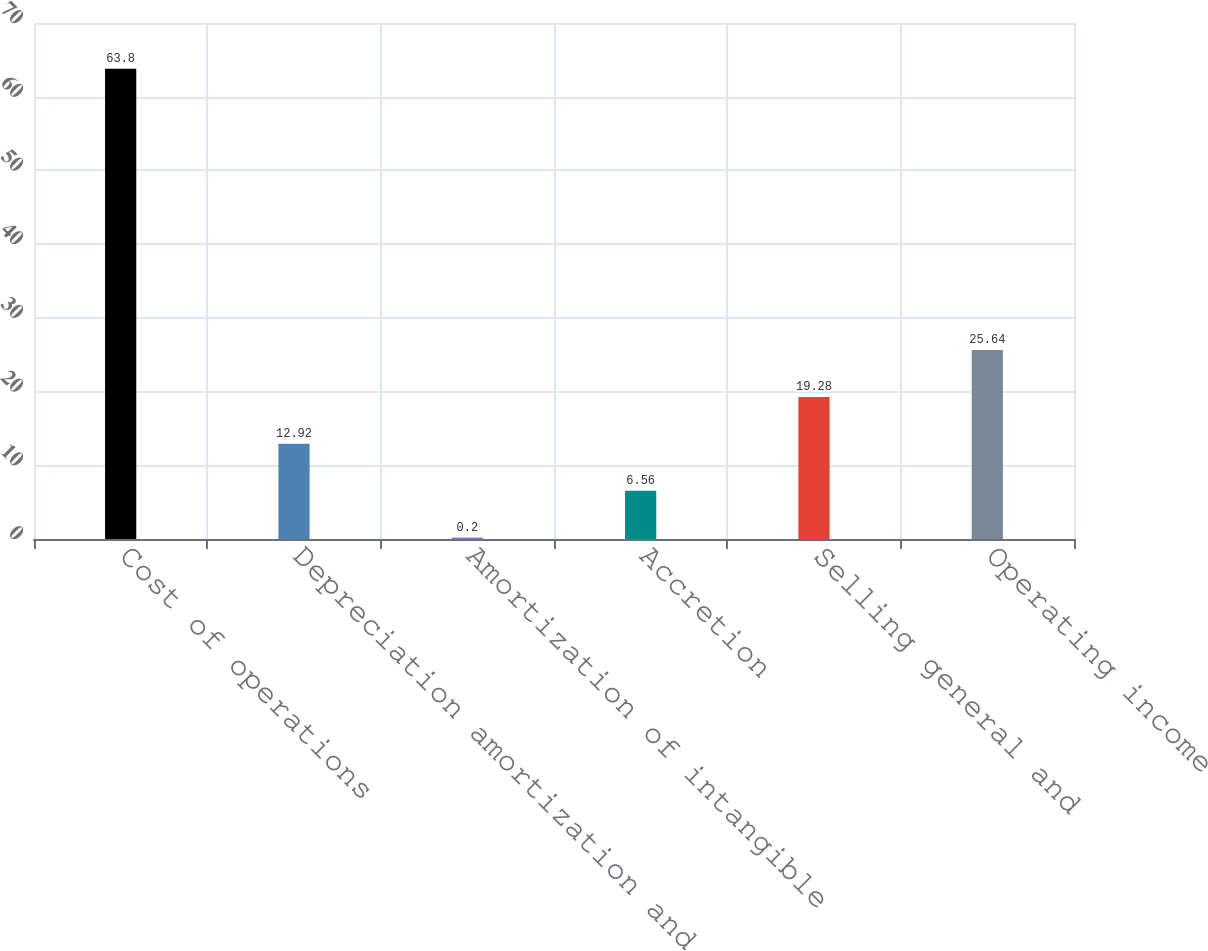<chart> <loc_0><loc_0><loc_500><loc_500><bar_chart><fcel>Cost of operations<fcel>Depreciation amortization and<fcel>Amortization of intangible<fcel>Accretion<fcel>Selling general and<fcel>Operating income<nl><fcel>63.8<fcel>12.92<fcel>0.2<fcel>6.56<fcel>19.28<fcel>25.64<nl></chart> 